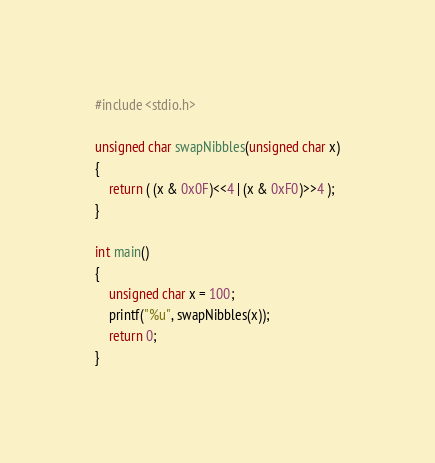Convert code to text. <code><loc_0><loc_0><loc_500><loc_500><_C_>#include <stdio.h>
 
unsigned char swapNibbles(unsigned char x)
{
    return ( (x & 0x0F)<<4 | (x & 0xF0)>>4 );
}
 
int main()
{
    unsigned char x = 100;
    printf("%u", swapNibbles(x));
    return 0;
}
</code> 